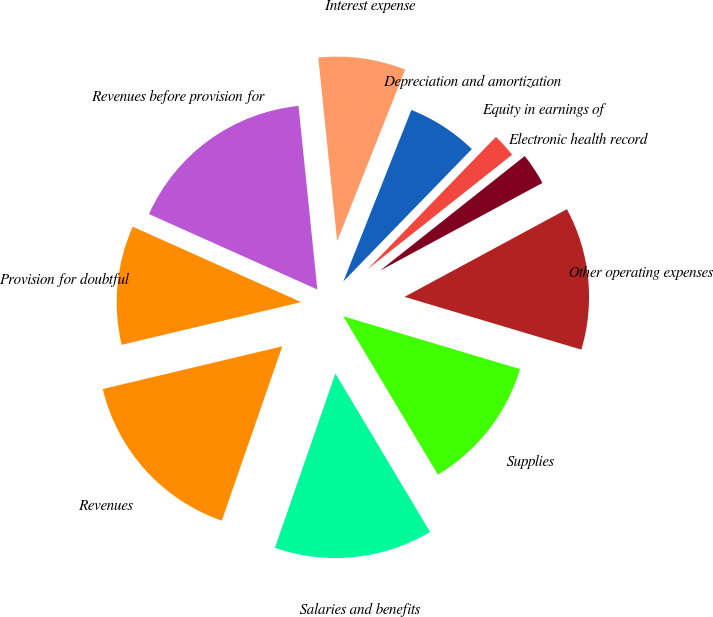Convert chart. <chart><loc_0><loc_0><loc_500><loc_500><pie_chart><fcel>Revenues before provision for<fcel>Provision for doubtful<fcel>Revenues<fcel>Salaries and benefits<fcel>Supplies<fcel>Other operating expenses<fcel>Electronic health record<fcel>Equity in earnings of<fcel>Depreciation and amortization<fcel>Interest expense<nl><fcel>16.67%<fcel>10.42%<fcel>15.97%<fcel>13.89%<fcel>11.81%<fcel>12.5%<fcel>2.78%<fcel>2.08%<fcel>6.25%<fcel>7.64%<nl></chart> 